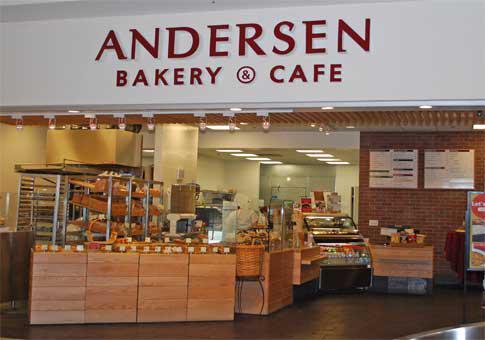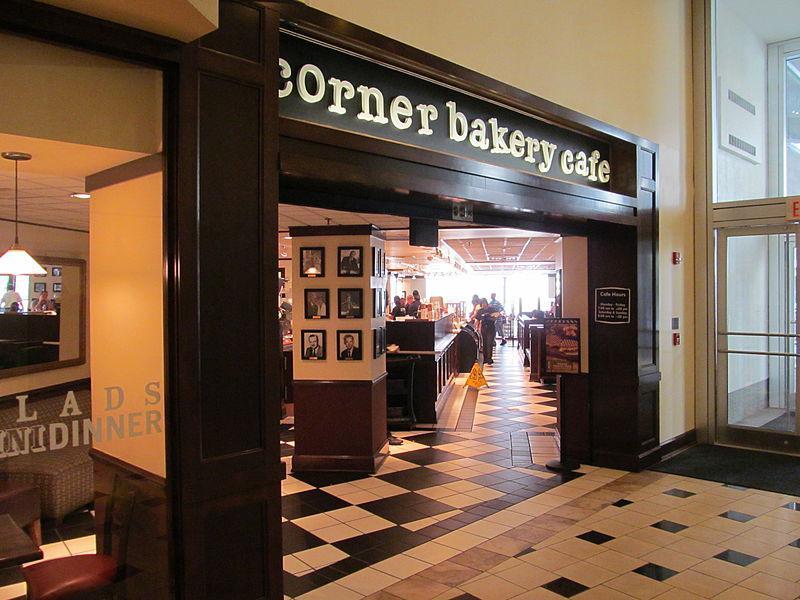The first image is the image on the left, the second image is the image on the right. Analyze the images presented: Is the assertion "An image includes a person behind a bakery counter and at least one back-turned person standing in front of the counter." valid? Answer yes or no. No. 